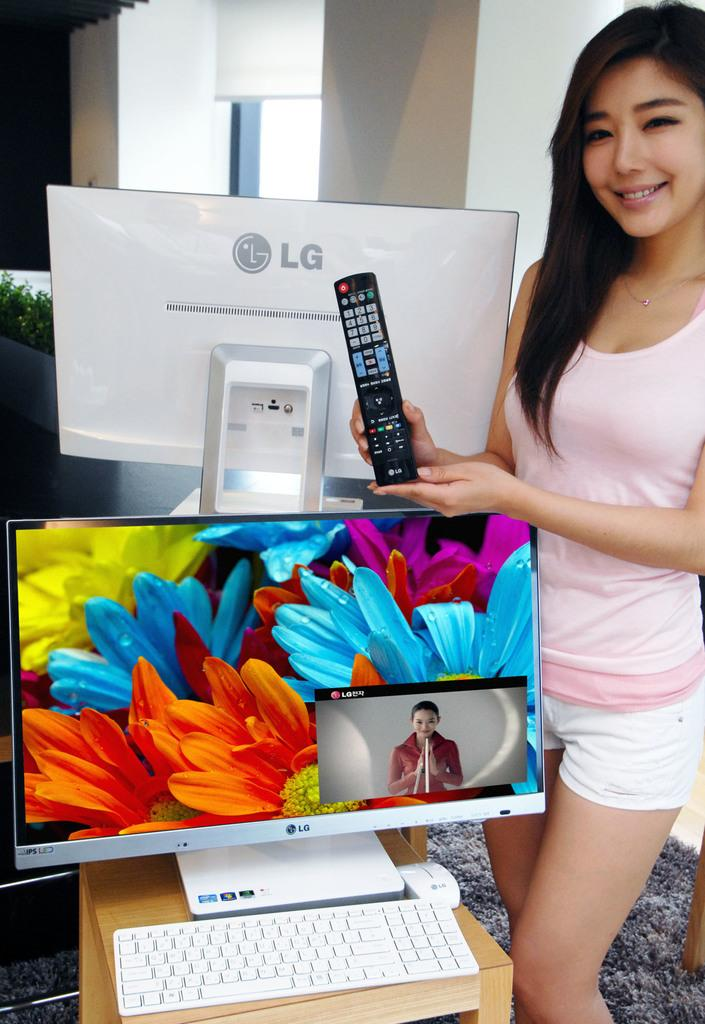<image>
Create a compact narrative representing the image presented. A girl holds a remote next to a LG monitor. 